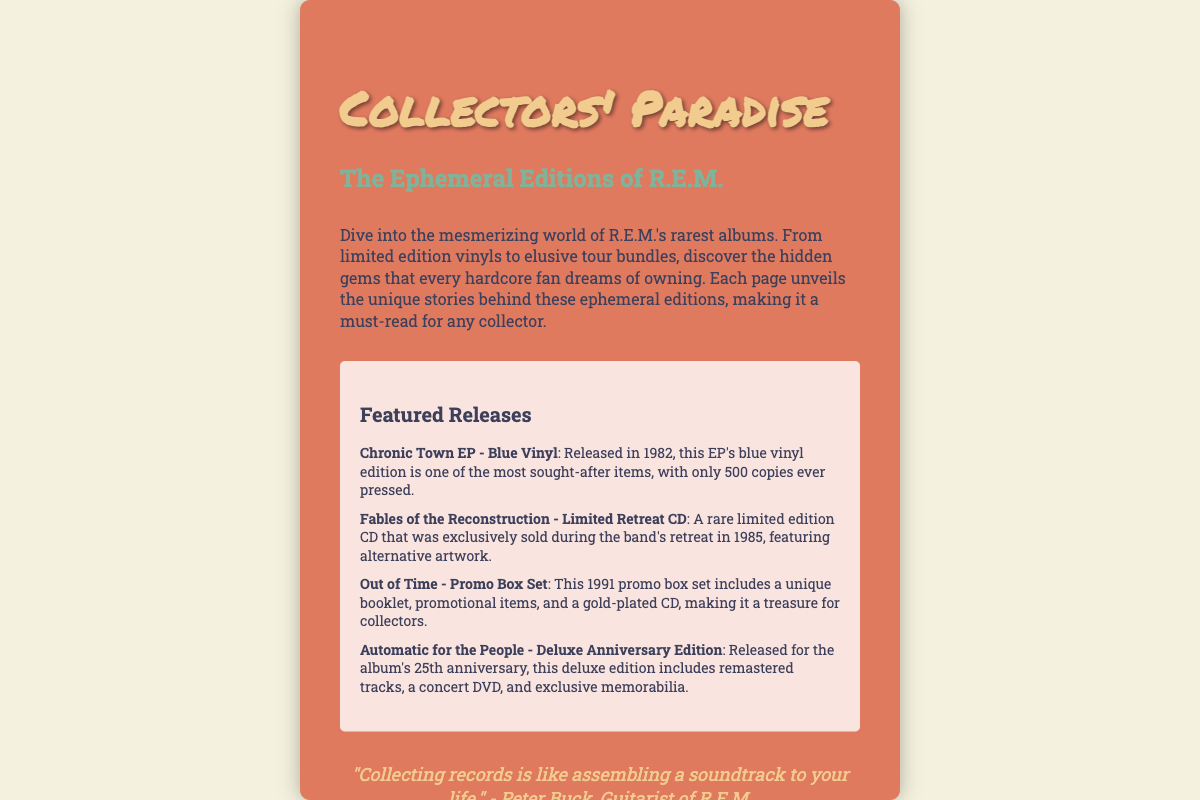What is the title of the book? The title of the book is found prominently on the cover in the largest font.
Answer: Collectors' Paradise Who is the author of the book? The author's name is listed on the cover, indicating who has written the book.
Answer: John Smith What year was the Chronic Town EP - Blue Vinyl released? The release year for the Chronic Town EP is mentioned next to its title in the featured releases section.
Answer: 1982 How many copies of the Chronic Town EP - Blue Vinyl were pressed? The document states the number of copies that were produced for the Chronic Town EP.
Answer: 500 What is included in the Out of Time - Promo Box Set? The featured releases detail what comes with the Out of Time promo set.
Answer: Booklet, promotional items, gold-plated CD Why is the Automatic for the People - Deluxe Anniversary Edition special? The document describes some unique features of this edition that sets it apart from others.
Answer: Remastered tracks, concert DVD, exclusive memorabilia What type of press published the book? The publisher's details on the cover identify what kind of press published the book.
Answer: Harmony Press What quote is attributed to Peter Buck? There is a specific quote attributed to Peter Buck in the quote section of the cover.
Answer: "Collecting records is like assembling a soundtrack to your life." How is the background of the book cover described? The style of the book cover is conveyed through the description of the collage in the document.
Answer: Vintage-styled with concert tickets and backstage passes 